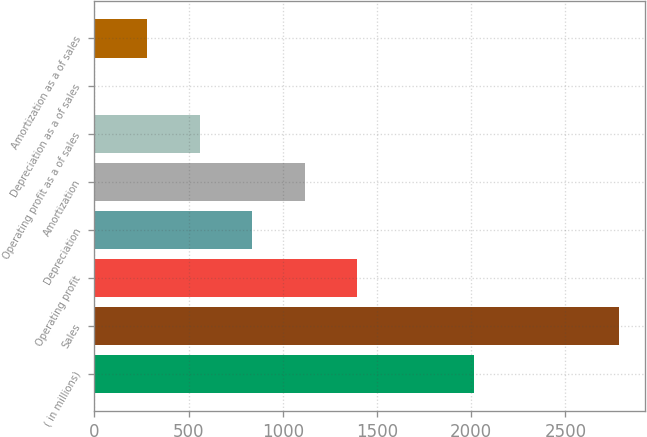Convert chart. <chart><loc_0><loc_0><loc_500><loc_500><bar_chart><fcel>( in millions)<fcel>Sales<fcel>Operating profit<fcel>Depreciation<fcel>Amortization<fcel>Operating profit as a of sales<fcel>Depreciation as a of sales<fcel>Amortization as a of sales<nl><fcel>2016<fcel>2785.4<fcel>1393.5<fcel>836.74<fcel>1115.12<fcel>558.36<fcel>1.6<fcel>279.98<nl></chart> 